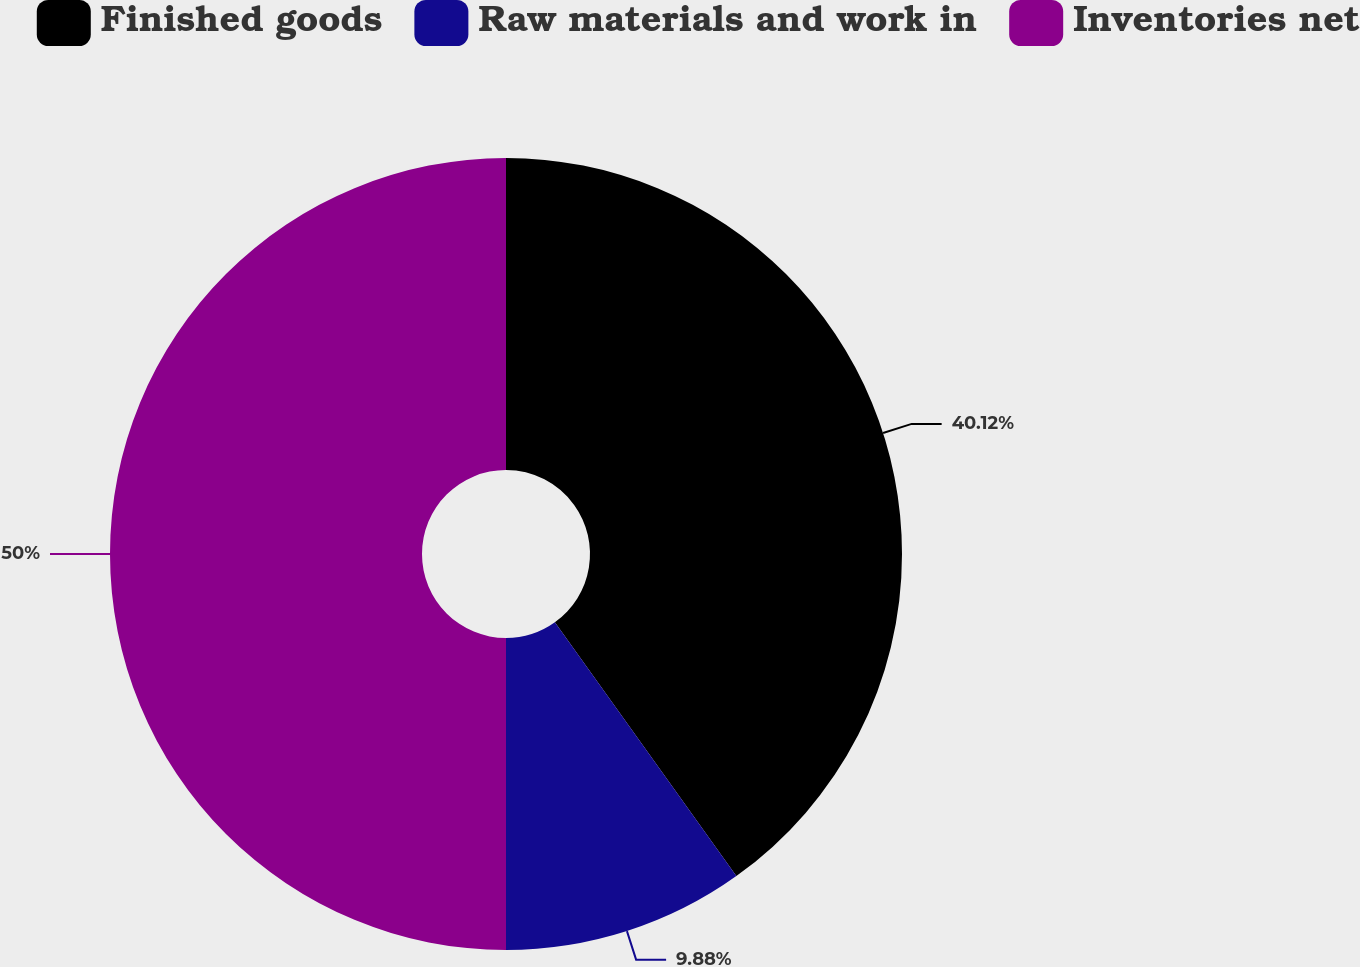<chart> <loc_0><loc_0><loc_500><loc_500><pie_chart><fcel>Finished goods<fcel>Raw materials and work in<fcel>Inventories net<nl><fcel>40.12%<fcel>9.88%<fcel>50.0%<nl></chart> 